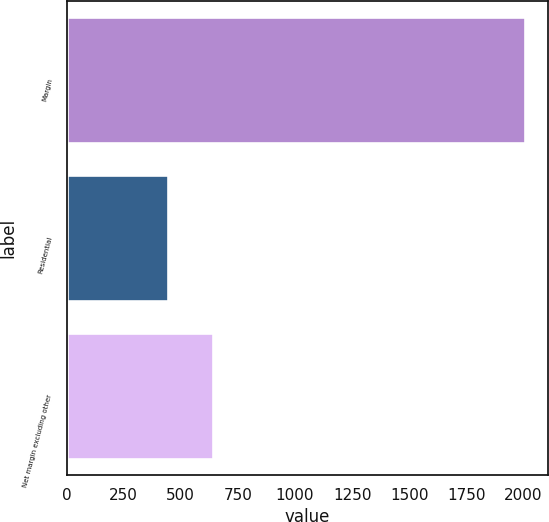Convert chart to OTSL. <chart><loc_0><loc_0><loc_500><loc_500><bar_chart><fcel>Margin<fcel>Residential<fcel>Net margin excluding other<nl><fcel>2008<fcel>444<fcel>639.6<nl></chart> 